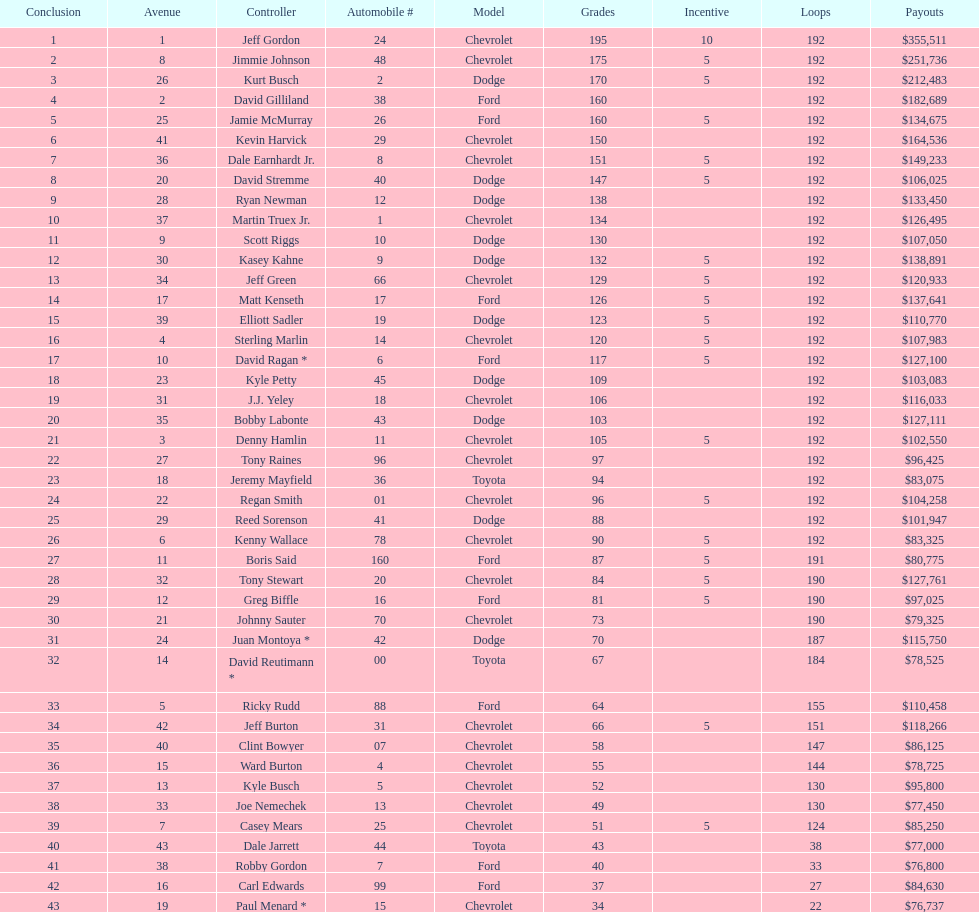What was the make of both jeff gordon's and jimmie johnson's race car? Chevrolet. 